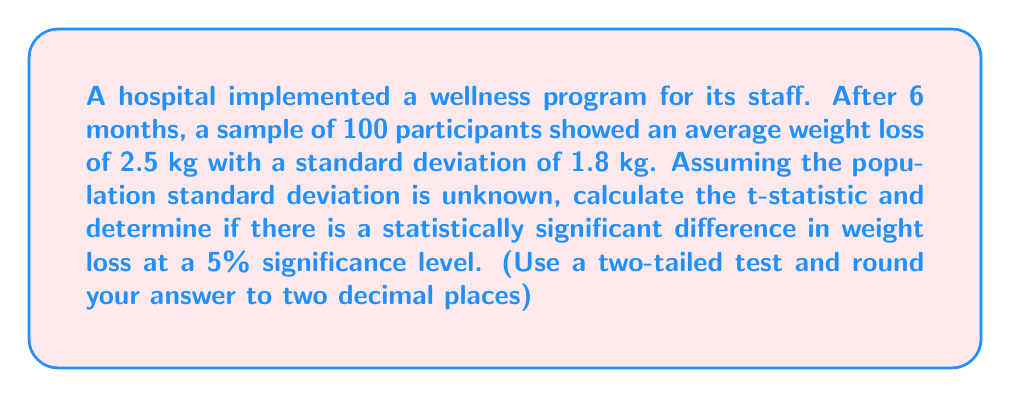Can you answer this question? To determine if there is a statistically significant difference in weight loss, we need to perform a one-sample t-test. Here are the steps:

1. State the null and alternative hypotheses:
   $H_0: \mu = 0$ (no significant weight loss)
   $H_a: \mu \neq 0$ (significant weight loss)

2. Calculate the t-statistic:
   The formula for the t-statistic is:
   $$t = \frac{\bar{x} - \mu_0}{s / \sqrt{n}}$$
   
   Where:
   $\bar{x}$ = sample mean (2.5 kg)
   $\mu_0$ = hypothesized population mean (0 kg, as per null hypothesis)
   $s$ = sample standard deviation (1.8 kg)
   $n$ = sample size (100)

   Plugging in the values:
   $$t = \frac{2.5 - 0}{1.8 / \sqrt{100}} = \frac{2.5}{1.8 / 10} = \frac{2.5}{0.18} = 13.89$$

3. Determine the critical t-value:
   For a two-tailed test at 5% significance level (α = 0.05) with 99 degrees of freedom (n-1), the critical t-value is approximately ±1.984 (from t-distribution table).

4. Compare the calculated t-statistic with the critical t-value:
   |13.89| > 1.984, so we reject the null hypothesis.

5. Interpret the result:
   Since the calculated t-statistic (13.89) is greater than the critical t-value (1.984), we reject the null hypothesis. This means there is strong evidence to suggest that the wellness program resulted in a statistically significant weight loss among staff members.
Answer: The t-statistic is 13.89. Since |13.89| > 1.984 (critical t-value), we reject the null hypothesis. There is a statistically significant difference in weight loss at the 5% significance level. 